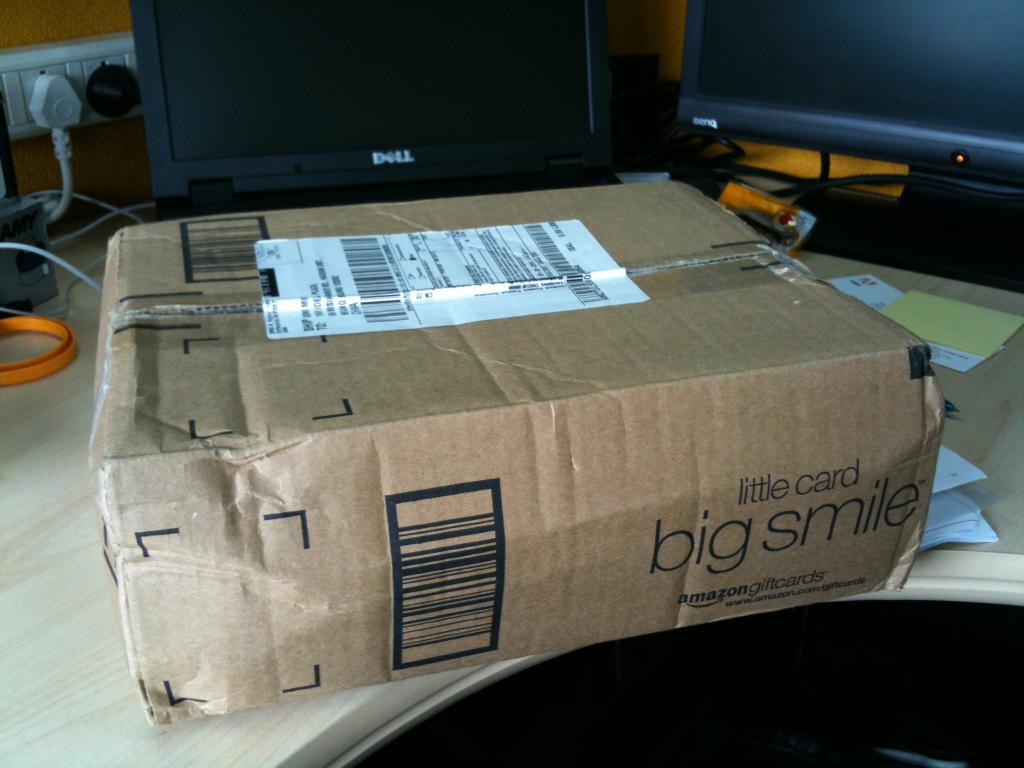Little card and big what?
Your answer should be very brief. Smile. 